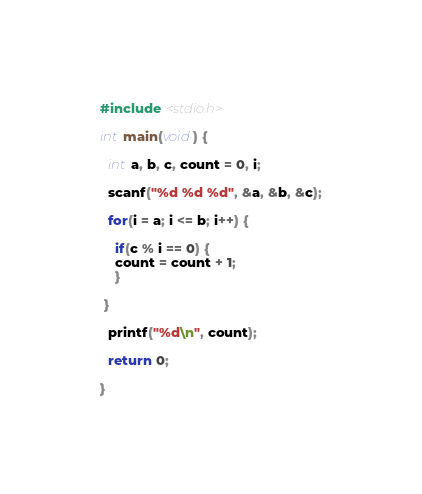Convert code to text. <code><loc_0><loc_0><loc_500><loc_500><_C_>#include <stdio.h>

int main(void) {

  int a, b, c, count = 0, i;

  scanf("%d %d %d", &a, &b, &c);

  for(i = a; i <= b; i++) {
    
    if(c % i == 0) {
    count = count + 1;
    }
 
 }
 
  printf("%d\n", count);

  return 0;
 
}</code> 